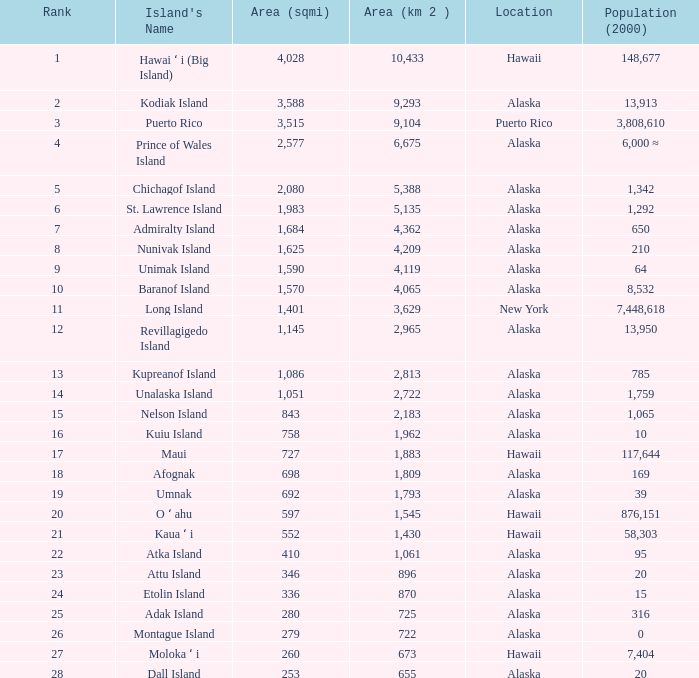Could you help me parse every detail presented in this table? {'header': ['Rank', "Island's Name", 'Area (sqmi)', 'Area (km 2 )', 'Location', 'Population (2000)'], 'rows': [['1', 'Hawai ʻ i (Big Island)', '4,028', '10,433', 'Hawaii', '148,677'], ['2', 'Kodiak Island', '3,588', '9,293', 'Alaska', '13,913'], ['3', 'Puerto Rico', '3,515', '9,104', 'Puerto Rico', '3,808,610'], ['4', 'Prince of Wales Island', '2,577', '6,675', 'Alaska', '6,000 ≈'], ['5', 'Chichagof Island', '2,080', '5,388', 'Alaska', '1,342'], ['6', 'St. Lawrence Island', '1,983', '5,135', 'Alaska', '1,292'], ['7', 'Admiralty Island', '1,684', '4,362', 'Alaska', '650'], ['8', 'Nunivak Island', '1,625', '4,209', 'Alaska', '210'], ['9', 'Unimak Island', '1,590', '4,119', 'Alaska', '64'], ['10', 'Baranof Island', '1,570', '4,065', 'Alaska', '8,532'], ['11', 'Long Island', '1,401', '3,629', 'New York', '7,448,618'], ['12', 'Revillagigedo Island', '1,145', '2,965', 'Alaska', '13,950'], ['13', 'Kupreanof Island', '1,086', '2,813', 'Alaska', '785'], ['14', 'Unalaska Island', '1,051', '2,722', 'Alaska', '1,759'], ['15', 'Nelson Island', '843', '2,183', 'Alaska', '1,065'], ['16', 'Kuiu Island', '758', '1,962', 'Alaska', '10'], ['17', 'Maui', '727', '1,883', 'Hawaii', '117,644'], ['18', 'Afognak', '698', '1,809', 'Alaska', '169'], ['19', 'Umnak', '692', '1,793', 'Alaska', '39'], ['20', 'O ʻ ahu', '597', '1,545', 'Hawaii', '876,151'], ['21', 'Kaua ʻ i', '552', '1,430', 'Hawaii', '58,303'], ['22', 'Atka Island', '410', '1,061', 'Alaska', '95'], ['23', 'Attu Island', '346', '896', 'Alaska', '20'], ['24', 'Etolin Island', '336', '870', 'Alaska', '15'], ['25', 'Adak Island', '280', '725', 'Alaska', '316'], ['26', 'Montague Island', '279', '722', 'Alaska', '0'], ['27', 'Moloka ʻ i', '260', '673', 'Hawaii', '7,404'], ['28', 'Dall Island', '253', '655', 'Alaska', '20']]} What is the largest rank with 2,080 area? 5.0. 